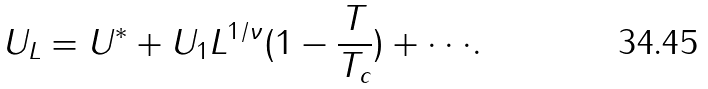<formula> <loc_0><loc_0><loc_500><loc_500>U _ { L } = U ^ { \ast } + U _ { 1 } L ^ { 1 / \nu } ( 1 - \frac { T } { T _ { c } } ) + \cdot \cdot \cdot .</formula> 